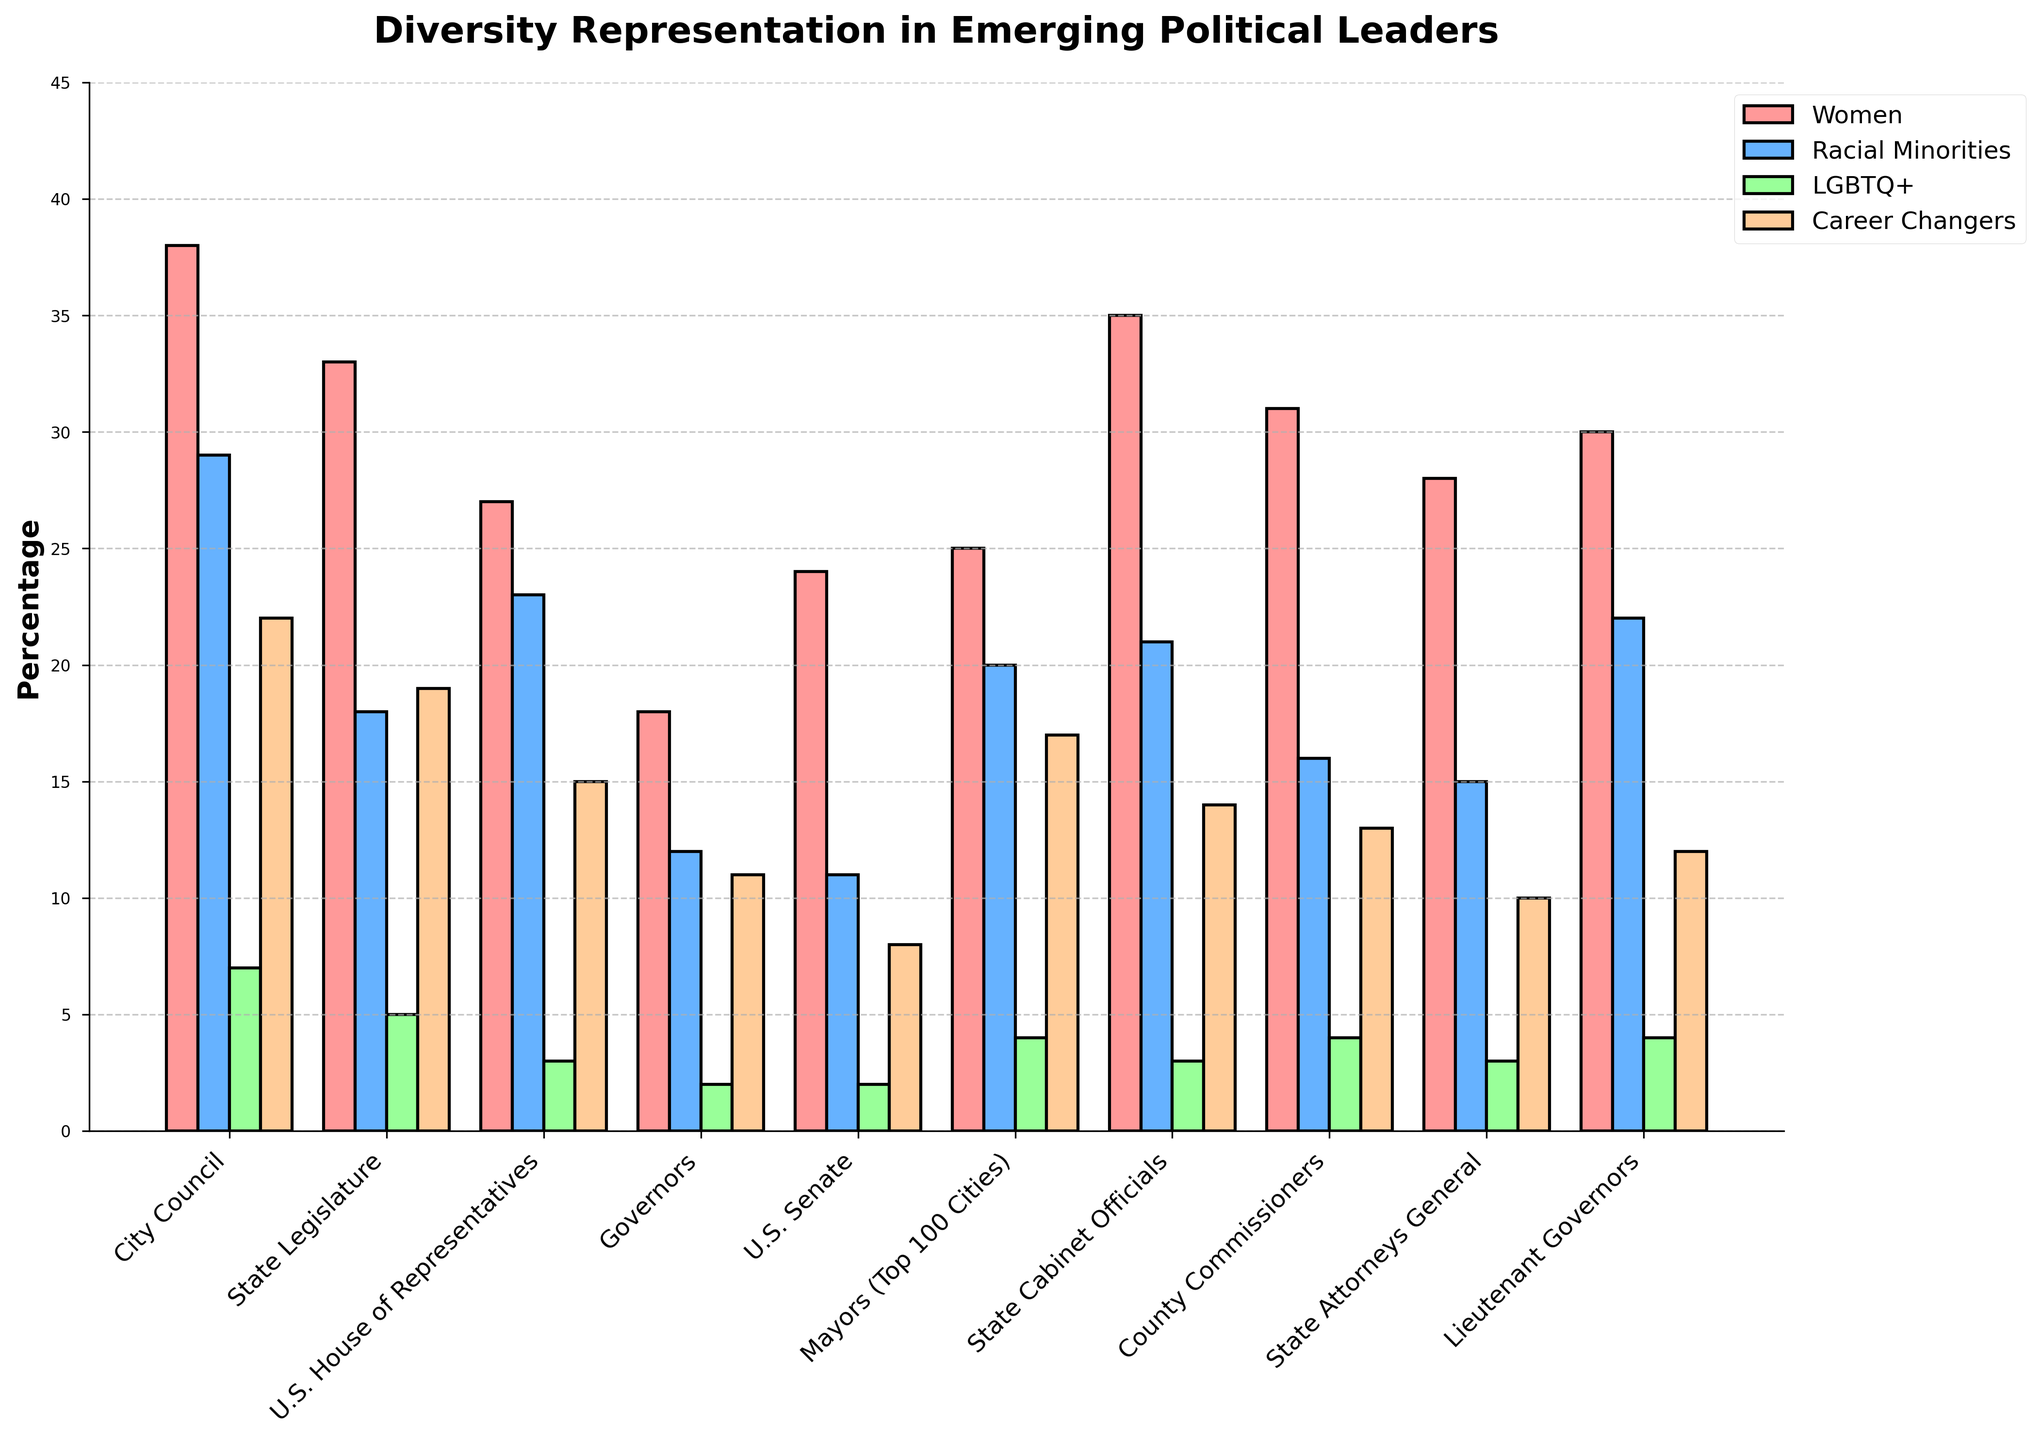Which office level has the highest representation of women? The tallest bar for women (pink color) represents the Office level with the highest percentage. By comparing the heights visually, City Council at 38% is the highest representation.
Answer: City Council What is the difference in racial minorities' representation between City Council and U.S. Senate? Find the value for racial minorities in City Council (29%) and U.S. Senate (11%), then subtract the latter from the former. 29% - 11% = 18%.
Answer: 18% Which office level has the lowest representation of LGBTQ+ individuals? Look for the shortest bar in blue, representing LGBTQ+ individuals. The lowest bar is for the Governors at 2%.
Answer: Governors What is the average representation of career changers across all office levels? Add the percentages of career changers from all the office levels and divide by the number of office levels: (22 + 19 + 15 + 11 + 8 + 17 + 14 + 13 + 10 + 12) / 10 = 141 / 10 = 14.1%.
Answer: 14.1% Are women or racial minorities more represented in State Legislature? Compare the values for women (red, 33%) and racial minorities (blue, 18%) in the State Legislature. Women have a higher percentage at 33%.
Answer: Women Which office level has the highest combined representation of racial minorities and LGBTQ+ individuals? Add the values for racial minorities and LGBTQ+ individuals for each office level, then compare the sums. City Council has 29% + 7% = 36%, which is the highest combined representation.
Answer: City Council Does the representation of women exceed 30% in U.S. House of Representatives? Check the value for women in U.S. House of Representatives. The value is 27%, which is less than 30%.
Answer: No What is the representation difference between women and career changers in the State Cabinet Officials? Find the percentages for both women (35%) and career changers (14%) in State Cabinet Officials, then subtract the smaller value from the larger one. 35% - 14% = 21%.
Answer: 21% Which group has the most evenly spread representation across all office levels? To find the most evenly spread group, compare the range (difference between the highest and lowest value) for each category. LGBTQ+ has values between 2% and 7%, which gives a range of 5%, making it consistent across levels.
Answer: LGBTQ+ Which groups' representation is consistently below 10% across all office levels? Visually inspect bars that are below the 10% line across all levels. LGBTQ+ individuals, who range from 2% to 7% across all office levels, fit this criterion.
Answer: LGBTQ+ 